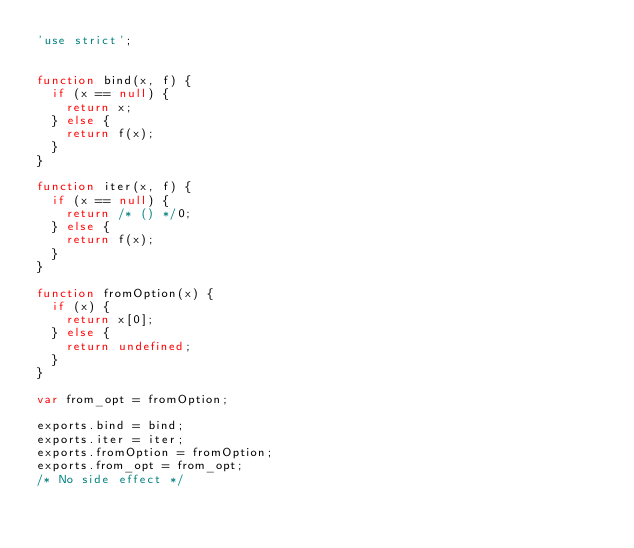<code> <loc_0><loc_0><loc_500><loc_500><_JavaScript_>'use strict';


function bind(x, f) {
  if (x == null) {
    return x;
  } else {
    return f(x);
  }
}

function iter(x, f) {
  if (x == null) {
    return /* () */0;
  } else {
    return f(x);
  }
}

function fromOption(x) {
  if (x) {
    return x[0];
  } else {
    return undefined;
  }
}

var from_opt = fromOption;

exports.bind = bind;
exports.iter = iter;
exports.fromOption = fromOption;
exports.from_opt = from_opt;
/* No side effect */
</code> 